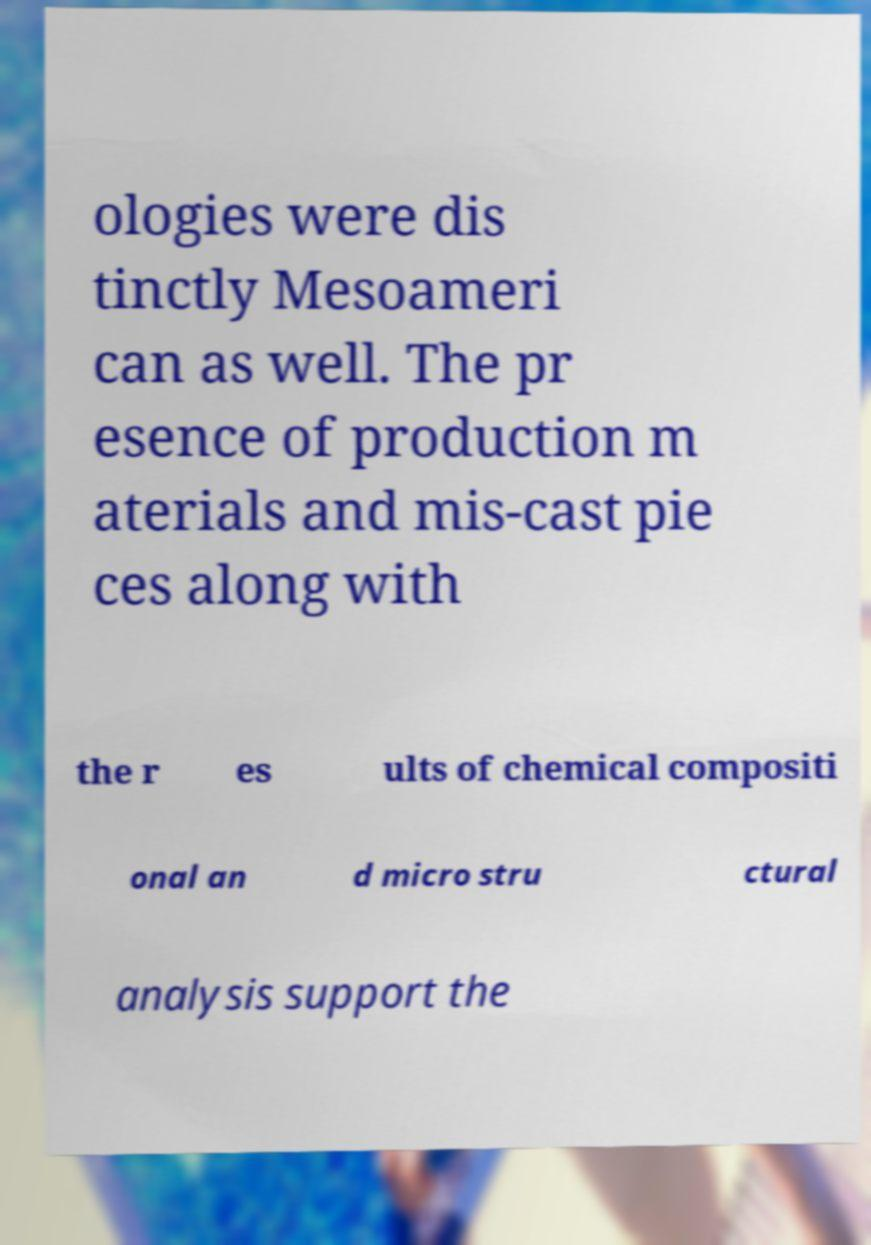I need the written content from this picture converted into text. Can you do that? ologies were dis tinctly Mesoameri can as well. The pr esence of production m aterials and mis-cast pie ces along with the r es ults of chemical compositi onal an d micro stru ctural analysis support the 